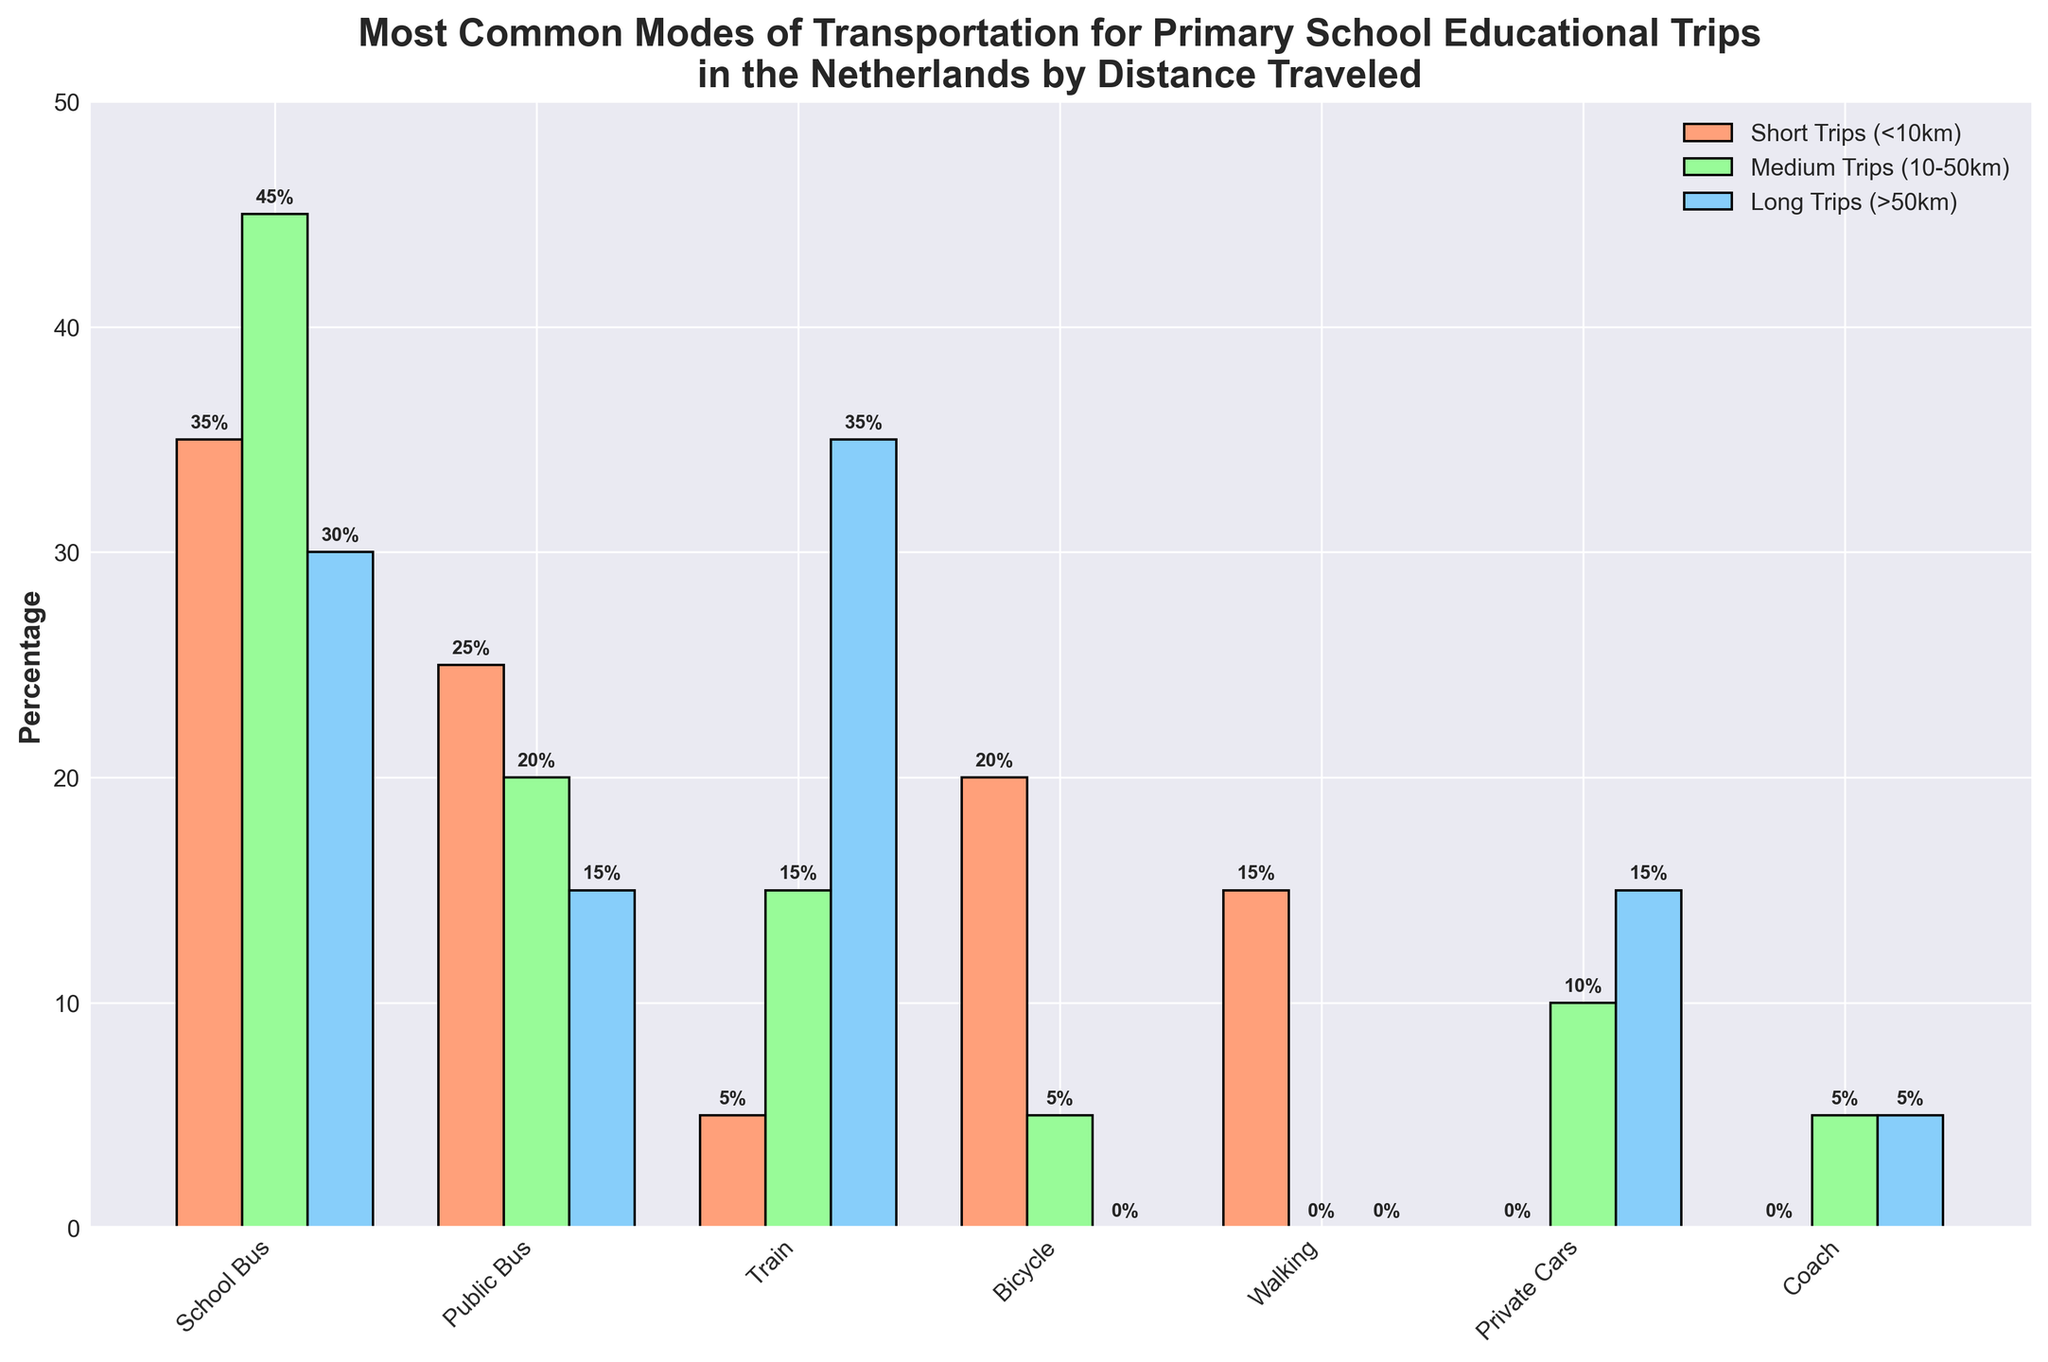What's the most common mode of transportation for short trips (<10km)? By looking at the heights of the bars for short trips, the School Bus has the highest bar compared to others with a value of 35%.
Answer: School Bus How does the usage of bicycles differ between short and medium trips? The height of the bar for bicycles in short trips shows usage at 20%, while for medium trips, it's much lower at 5%. The difference is 20% - 5% = 15%.
Answer: 15% Which mode of transportation is equally used for medium and long trips, and what percentage is it? Visually comparing the bars, the Coach mode has bars of equal height for medium and long trips, both at 5%.
Answer: Coach, 5% What is the sum of percentages for public buses across all distance categories? Sum up the heights of the bars for public buses in short (25%), medium (20%), and long trips (15%). 25% + 20% + 15% = 60%.
Answer: 60% For short trips, which modes have a higher percentage than walking? By comparing the heights of bars for short trips, School Bus (35%), Public Bus (25%), and Bicycle (20%) have higher percentages than Walking (15%).
Answer: School Bus, Public Bus, Bicycle Which mode of transportation has the least usage for long trips? The plot shows the smallest bar height for long trips is for Walking and Bicycle, both at 0%.
Answer: Walking, Bicycle How does the usage of private cars change from medium to long trips? The bar height for private cars in medium trips is 10%, and for long trips, it increases to 15%. The change is 15% - 10% = 5%.
Answer: 5% Which trip category has the highest overall usage of school buses? Comparing the heights of the school bus bars for short (35%), medium (45%), and long trips (30%), medium trips have the highest usage.
Answer: Medium trips What is the average usage of trains across all distance categories? Adding the percentages for trains in short (5%), medium (15%), and long trips (35%): 5% + 15% + 35% = 55%. The average is 55% / 3 = 18.33%.
Answer: 18.33% Which modes of transportation are not used at all in one of the distance categories? From the plot, Walking is not used at all for medium and long trips, Bicycle for long trips, Private Cars and Coach for short trips.
Answer: Walking, Bicycle, Private Cars, Coach 